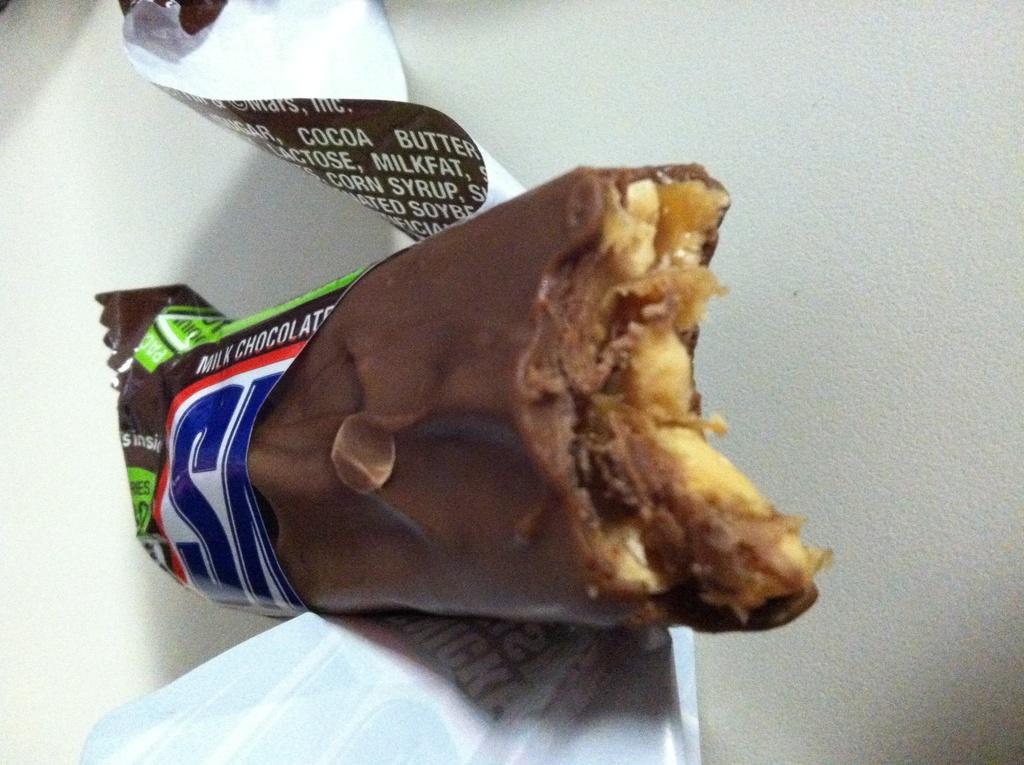How would you summarize this image in a sentence or two? It is a chocolate in brown color. 